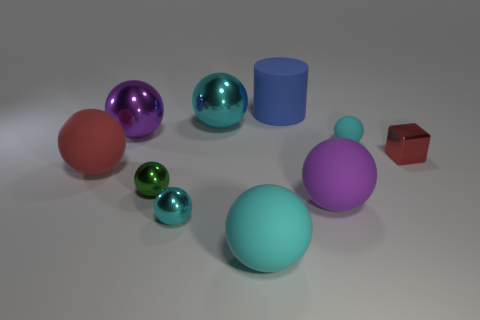Does the cylinder have the same material as the purple sphere that is in front of the red sphere?
Provide a short and direct response. Yes. Is there anything else that is the same shape as the purple shiny object?
Your answer should be very brief. Yes. What is the color of the metal thing that is both on the right side of the small green metal thing and in front of the large red sphere?
Give a very brief answer. Cyan. The tiny cyan thing in front of the large red object has what shape?
Ensure brevity in your answer.  Sphere. What is the size of the matte thing to the left of the large matte thing that is in front of the tiny cyan thing that is in front of the small shiny cube?
Keep it short and to the point. Large. What number of tiny metallic balls are in front of the big purple ball that is to the right of the big blue object?
Ensure brevity in your answer.  1. What size is the ball that is in front of the tiny cyan rubber object and on the right side of the rubber cylinder?
Provide a short and direct response. Large. How many metal objects are tiny cyan things or small yellow cubes?
Provide a succinct answer. 1. What is the green ball made of?
Ensure brevity in your answer.  Metal. The small cyan thing in front of the purple ball that is to the right of the large purple ball that is on the left side of the large cyan metallic thing is made of what material?
Make the answer very short. Metal. 